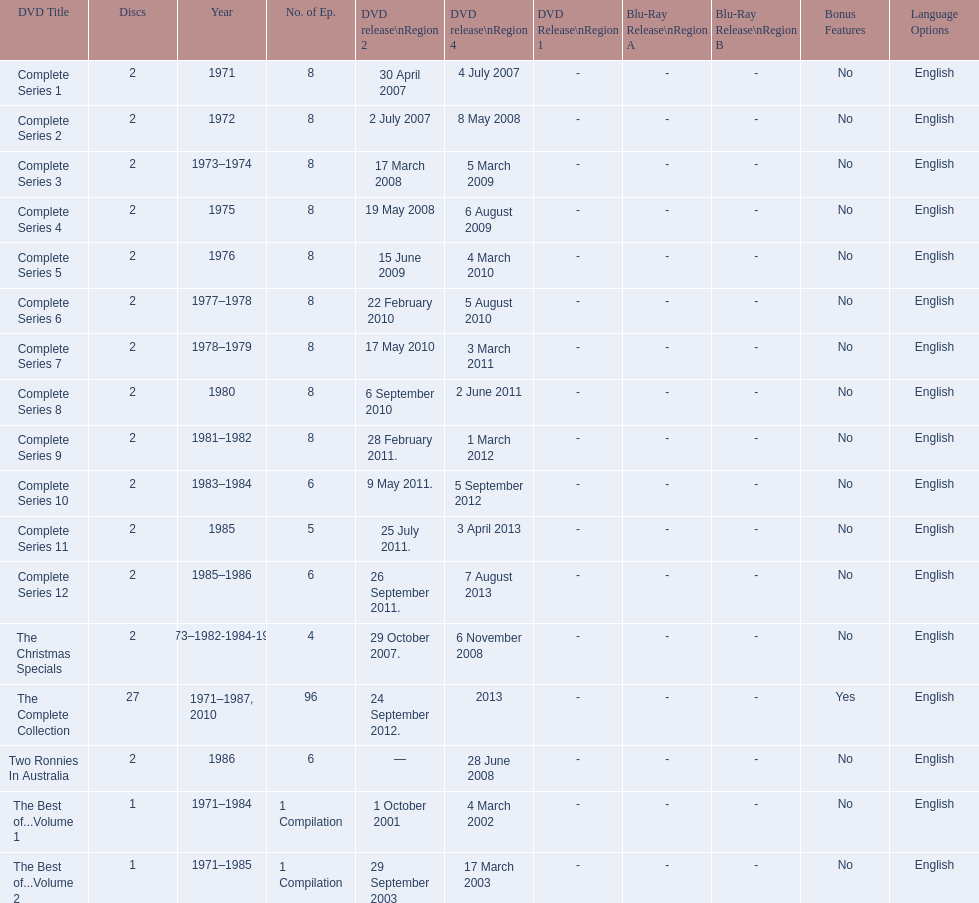How many series had 8 episodes? 9. 